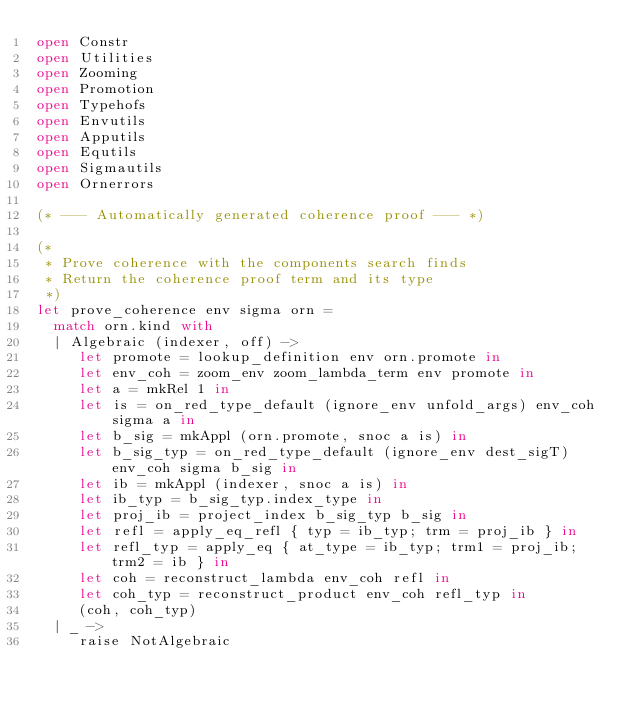<code> <loc_0><loc_0><loc_500><loc_500><_OCaml_>open Constr
open Utilities
open Zooming
open Promotion
open Typehofs
open Envutils
open Apputils
open Equtils
open Sigmautils
open Ornerrors
       
(* --- Automatically generated coherence proof --- *)

(* 
 * Prove coherence with the components search finds
 * Return the coherence proof term and its type
 *)
let prove_coherence env sigma orn =
  match orn.kind with
  | Algebraic (indexer, off) ->
     let promote = lookup_definition env orn.promote in
     let env_coh = zoom_env zoom_lambda_term env promote in
     let a = mkRel 1 in
     let is = on_red_type_default (ignore_env unfold_args) env_coh sigma a in
     let b_sig = mkAppl (orn.promote, snoc a is) in
     let b_sig_typ = on_red_type_default (ignore_env dest_sigT) env_coh sigma b_sig in
     let ib = mkAppl (indexer, snoc a is) in
     let ib_typ = b_sig_typ.index_type in
     let proj_ib = project_index b_sig_typ b_sig in
     let refl = apply_eq_refl { typ = ib_typ; trm = proj_ib } in
     let refl_typ = apply_eq { at_type = ib_typ; trm1 = proj_ib; trm2 = ib } in
     let coh = reconstruct_lambda env_coh refl in
     let coh_typ = reconstruct_product env_coh refl_typ in
     (coh, coh_typ)
  | _ ->
     raise NotAlgebraic
</code> 